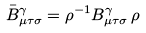<formula> <loc_0><loc_0><loc_500><loc_500>\bar { B } ^ { \gamma } _ { \mu \tau \sigma } = \rho ^ { - 1 } B ^ { \gamma } _ { \mu \tau \sigma } \, \rho</formula> 